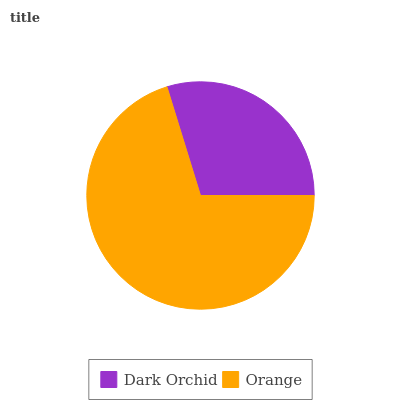Is Dark Orchid the minimum?
Answer yes or no. Yes. Is Orange the maximum?
Answer yes or no. Yes. Is Orange the minimum?
Answer yes or no. No. Is Orange greater than Dark Orchid?
Answer yes or no. Yes. Is Dark Orchid less than Orange?
Answer yes or no. Yes. Is Dark Orchid greater than Orange?
Answer yes or no. No. Is Orange less than Dark Orchid?
Answer yes or no. No. Is Orange the high median?
Answer yes or no. Yes. Is Dark Orchid the low median?
Answer yes or no. Yes. Is Dark Orchid the high median?
Answer yes or no. No. Is Orange the low median?
Answer yes or no. No. 